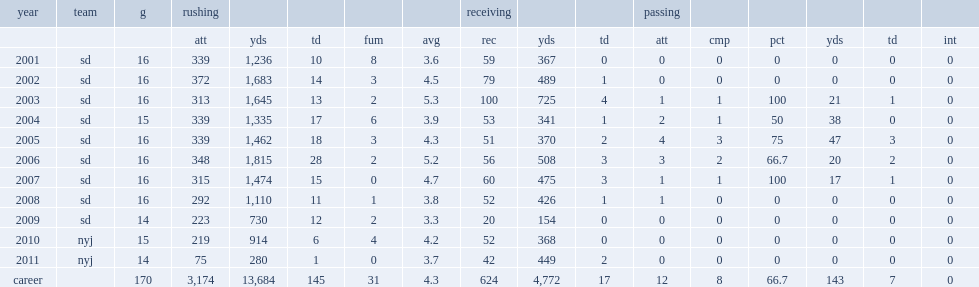How many rushing yards did ladainian tomlinson make in 2007? 1474.0. 